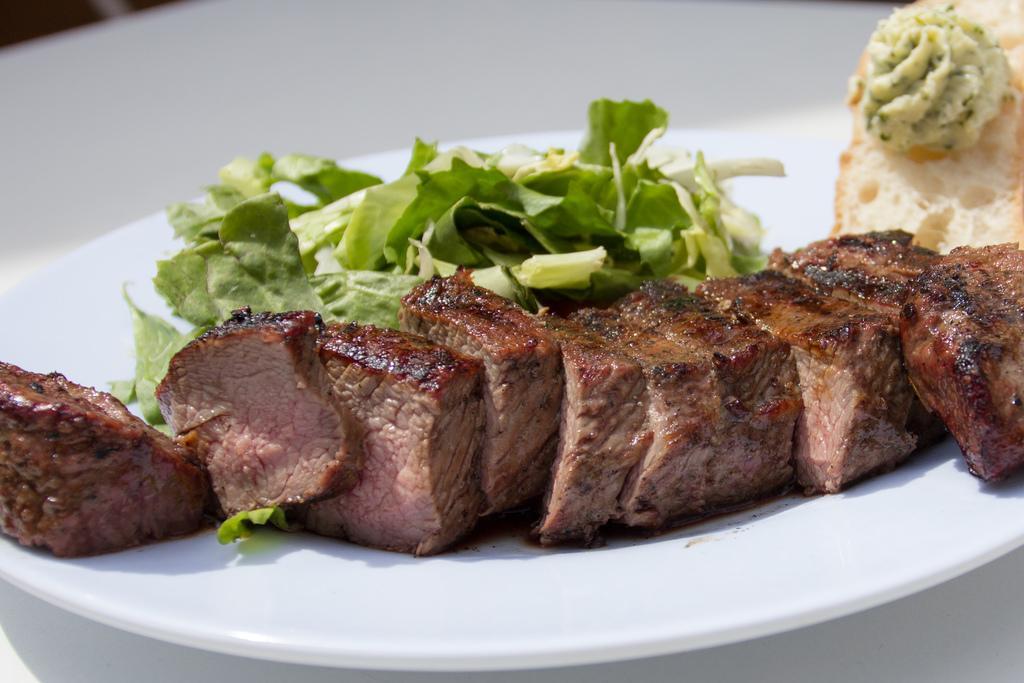Can you describe this image briefly? In this image we can see some food items placed on white plate. 